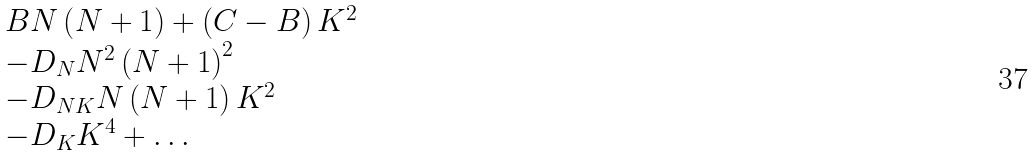Convert formula to latex. <formula><loc_0><loc_0><loc_500><loc_500>\begin{array} { l } B N \left ( { N + 1 } \right ) + \left ( { C - B } \right ) K ^ { 2 } \\ - D _ { N } N ^ { 2 } \left ( { N + 1 } \right ) ^ { 2 } \\ - D _ { N K } N \left ( { N + 1 } \right ) K ^ { 2 } \\ - D _ { K } K ^ { 4 } + \dots \\ \end{array}</formula> 